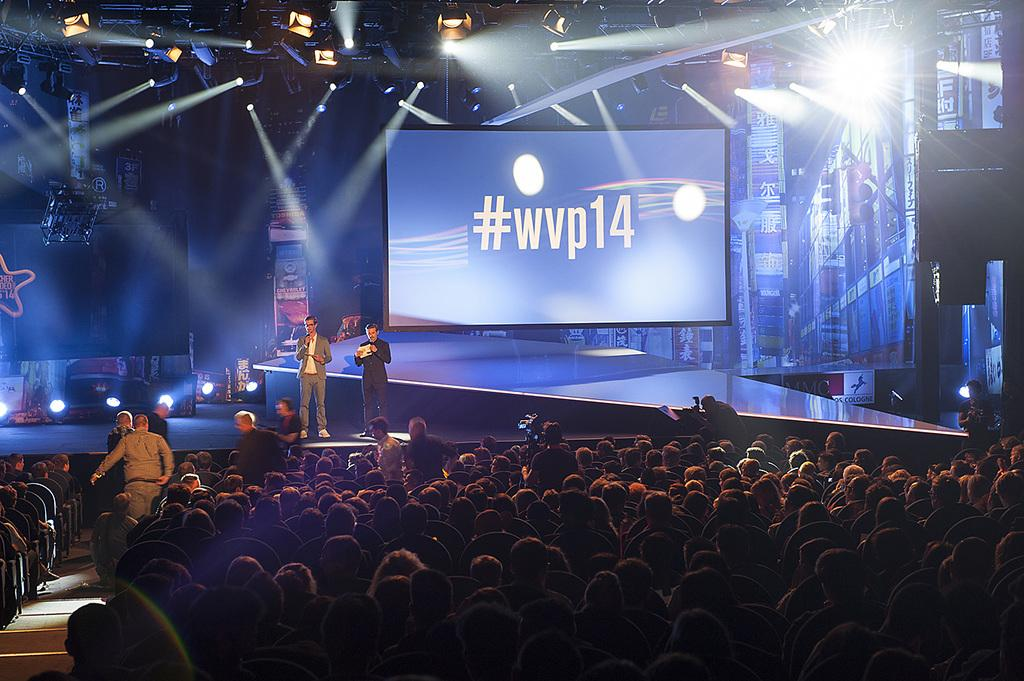<image>
Share a concise interpretation of the image provided. A large display on a stage with the hashtag #wvp14 on a blue background. 